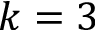Convert formula to latex. <formula><loc_0><loc_0><loc_500><loc_500>k = 3</formula> 